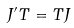Convert formula to latex. <formula><loc_0><loc_0><loc_500><loc_500>J ^ { \prime } T = T J</formula> 